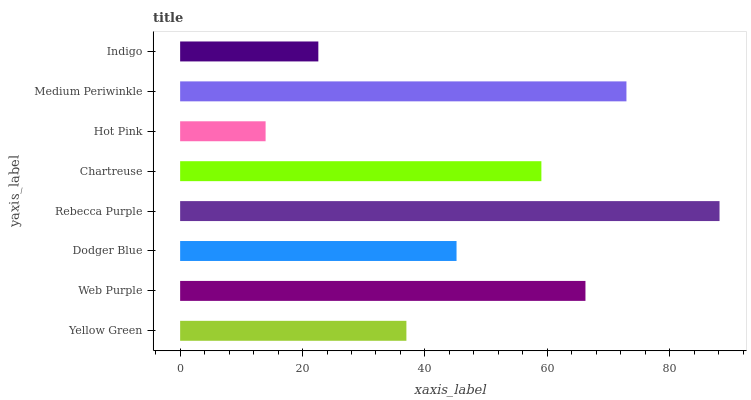Is Hot Pink the minimum?
Answer yes or no. Yes. Is Rebecca Purple the maximum?
Answer yes or no. Yes. Is Web Purple the minimum?
Answer yes or no. No. Is Web Purple the maximum?
Answer yes or no. No. Is Web Purple greater than Yellow Green?
Answer yes or no. Yes. Is Yellow Green less than Web Purple?
Answer yes or no. Yes. Is Yellow Green greater than Web Purple?
Answer yes or no. No. Is Web Purple less than Yellow Green?
Answer yes or no. No. Is Chartreuse the high median?
Answer yes or no. Yes. Is Dodger Blue the low median?
Answer yes or no. Yes. Is Dodger Blue the high median?
Answer yes or no. No. Is Yellow Green the low median?
Answer yes or no. No. 